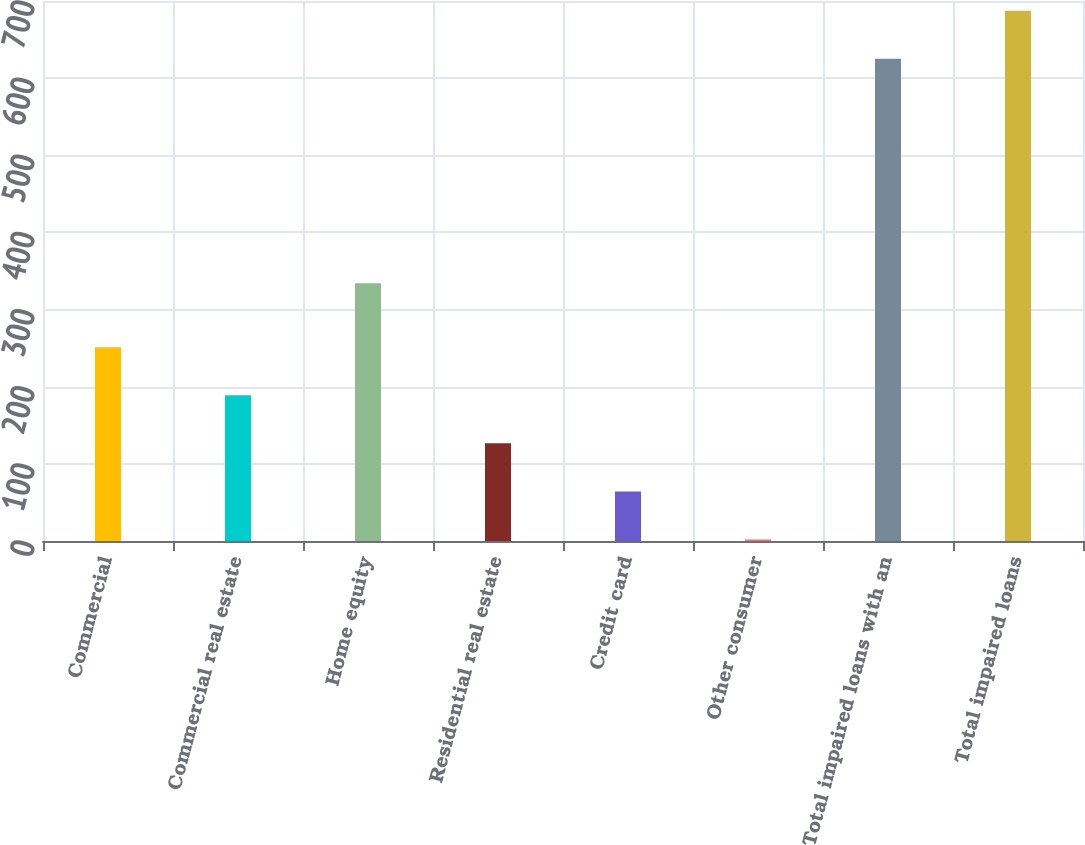Convert chart. <chart><loc_0><loc_0><loc_500><loc_500><bar_chart><fcel>Commercial<fcel>Commercial real estate<fcel>Home equity<fcel>Residential real estate<fcel>Credit card<fcel>Other consumer<fcel>Total impaired loans with an<fcel>Total impaired loans<nl><fcel>251.2<fcel>188.9<fcel>334<fcel>126.6<fcel>64.3<fcel>2<fcel>625<fcel>687.3<nl></chart> 